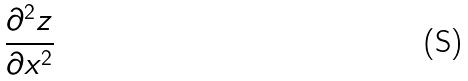<formula> <loc_0><loc_0><loc_500><loc_500>\frac { \partial ^ { 2 } z } { \partial x ^ { 2 } }</formula> 